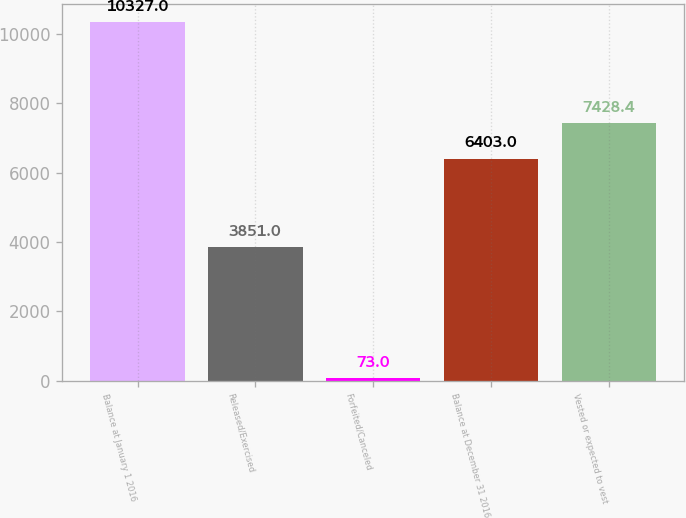Convert chart to OTSL. <chart><loc_0><loc_0><loc_500><loc_500><bar_chart><fcel>Balance at January 1 2016<fcel>Released/Exercised<fcel>Forfeited/Canceled<fcel>Balance at December 31 2016<fcel>Vested or expected to vest<nl><fcel>10327<fcel>3851<fcel>73<fcel>6403<fcel>7428.4<nl></chart> 